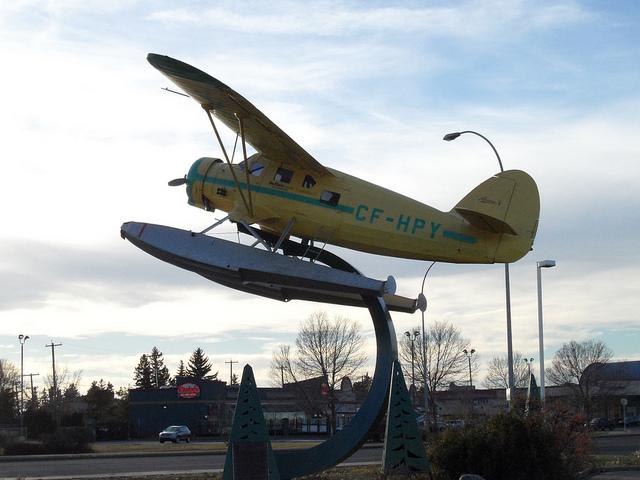Is the airplane flying?
Short answer required. No. What kind of airplane is this?
Concise answer only. Cf-hpy. What town is this?
Concise answer only. Seattle. 